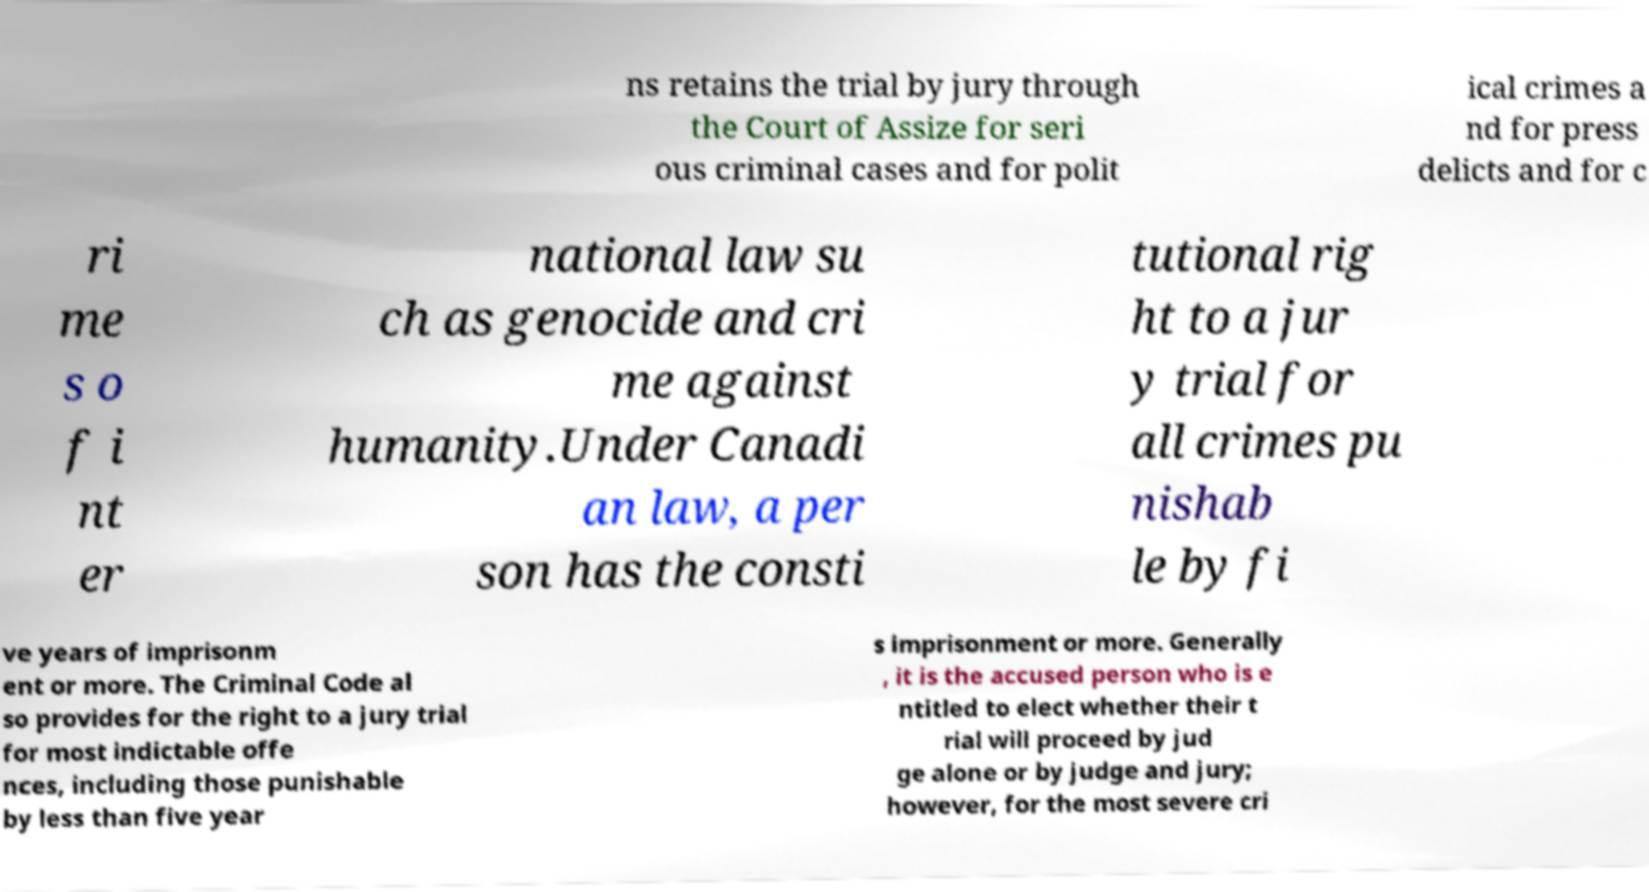What messages or text are displayed in this image? I need them in a readable, typed format. ns retains the trial by jury through the Court of Assize for seri ous criminal cases and for polit ical crimes a nd for press delicts and for c ri me s o f i nt er national law su ch as genocide and cri me against humanity.Under Canadi an law, a per son has the consti tutional rig ht to a jur y trial for all crimes pu nishab le by fi ve years of imprisonm ent or more. The Criminal Code al so provides for the right to a jury trial for most indictable offe nces, including those punishable by less than five year s imprisonment or more. Generally , it is the accused person who is e ntitled to elect whether their t rial will proceed by jud ge alone or by judge and jury; however, for the most severe cri 